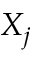<formula> <loc_0><loc_0><loc_500><loc_500>X _ { j }</formula> 